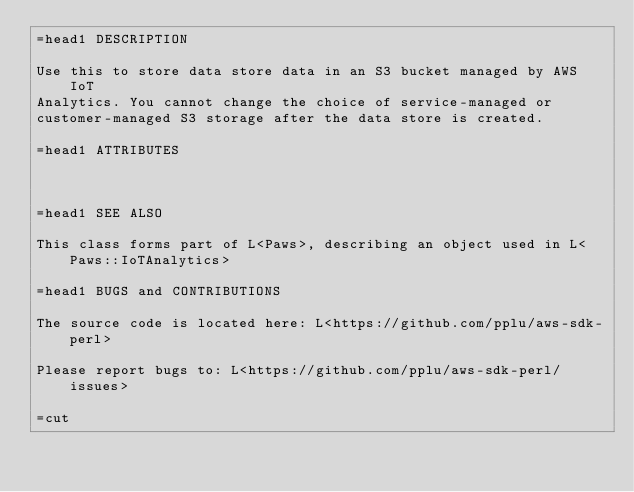Convert code to text. <code><loc_0><loc_0><loc_500><loc_500><_Perl_>=head1 DESCRIPTION

Use this to store data store data in an S3 bucket managed by AWS IoT
Analytics. You cannot change the choice of service-managed or
customer-managed S3 storage after the data store is created.

=head1 ATTRIBUTES



=head1 SEE ALSO

This class forms part of L<Paws>, describing an object used in L<Paws::IoTAnalytics>

=head1 BUGS and CONTRIBUTIONS

The source code is located here: L<https://github.com/pplu/aws-sdk-perl>

Please report bugs to: L<https://github.com/pplu/aws-sdk-perl/issues>

=cut

</code> 